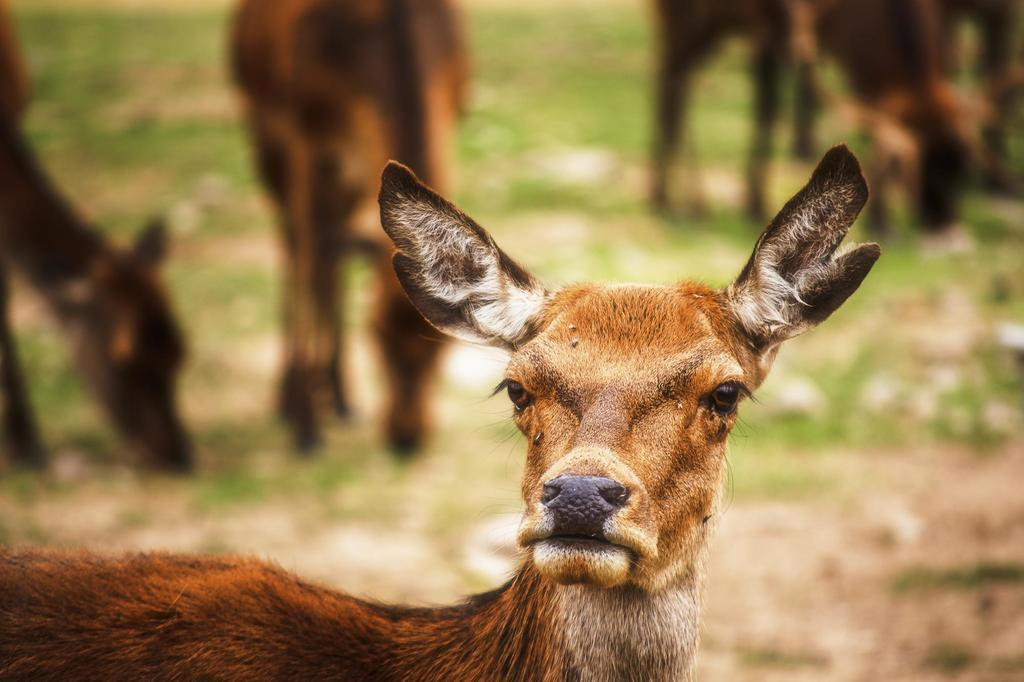What animals are present in the image? There are deers in the image. Can you describe the background of the image? The background of the image is blurred. What type of pipe is being used by the deer in the image? There is no pipe present in the image, as it features deers in an unspecified setting. 